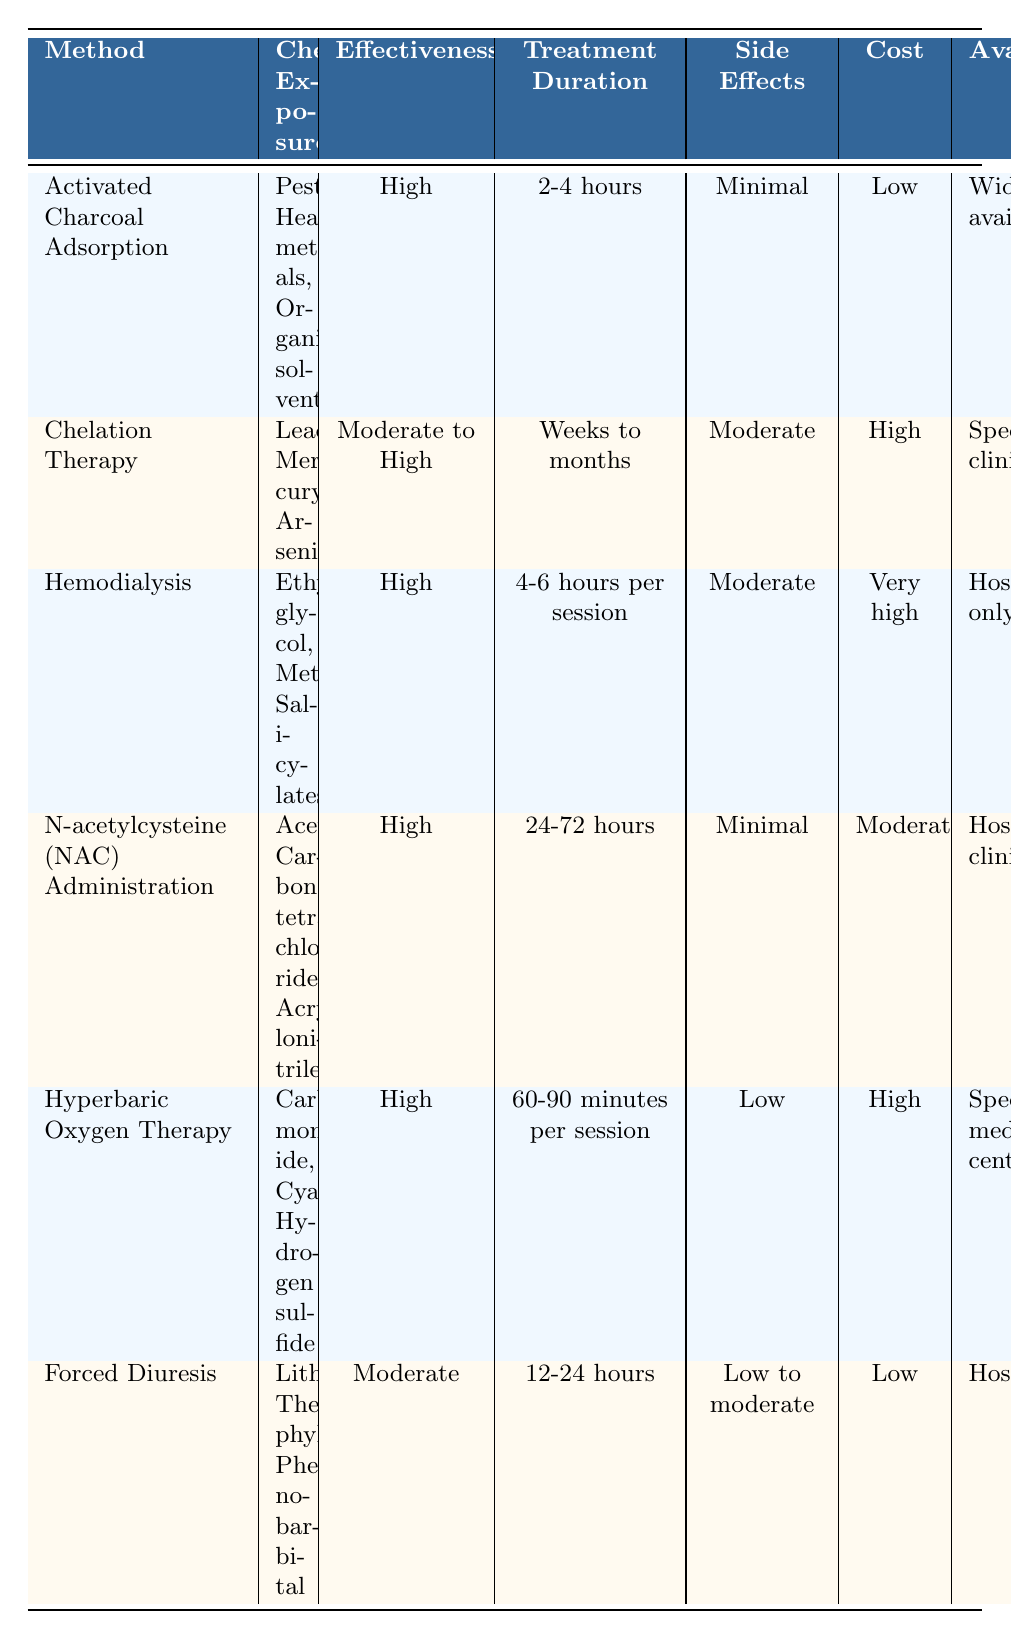What is the effectiveness rating of Activated Charcoal Adsorption? The effectiveness for Activated Charcoal Adsorption is listed as "High" in the table.
Answer: High Which detoxification method has the longest treatment duration? Chelation Therapy has the longest treatment duration listed as "Weeks to months" compared to the other methods.
Answer: Chelation Therapy Are side effects considered minimal for N-acetylcysteine (NAC) Administration? Yes, the side effects for N-acetylcysteine (NAC) Administration are noted as "Minimal" in the table.
Answer: Yes Which method is both low in cost and widely available? Activated Charcoal Adsorption is the method that is low in cost and widely available, based on the information provided in the table.
Answer: Activated Charcoal Adsorption What is the treatment duration for Hyperbaric Oxygen Therapy? The treatment duration for Hyperbaric Oxygen Therapy is listed as "60-90 minutes per session" in the table.
Answer: 60-90 minutes per session How many detoxification methods have a side effect rating of "Moderate"? Looking at the table, two methods—Chelation Therapy and Hemodialysis—are listed with a side effect rating of "Moderate," thus the answer is 2.
Answer: 2 Is Forced Diuresis effective for all the listed chemical exposures? No, Forced Diuresis is only marked as "Moderate" in effectiveness, indicating that it may not be effective for all listed chemicals.
Answer: No Which detoxification method is available at specialized clinics? Both Chelation Therapy and Hyperbaric Oxygen Therapy are available at specialized clinics as indicated in the table.
Answer: Chelation Therapy, Hyperbaric Oxygen Therapy What is the average cost of the detoxification methods listed? The average cost can be calculated as follows: (Low + High + Very high + Moderate + High + Low) involves categorizing costs as Low=1, Moderate=2, High=3, Very High=4, which gives an average of (1 + 3 + 4 + 2 + 3 + 1)/6 = 2.33, corresponding to average cost "Moderate."
Answer: Moderate 